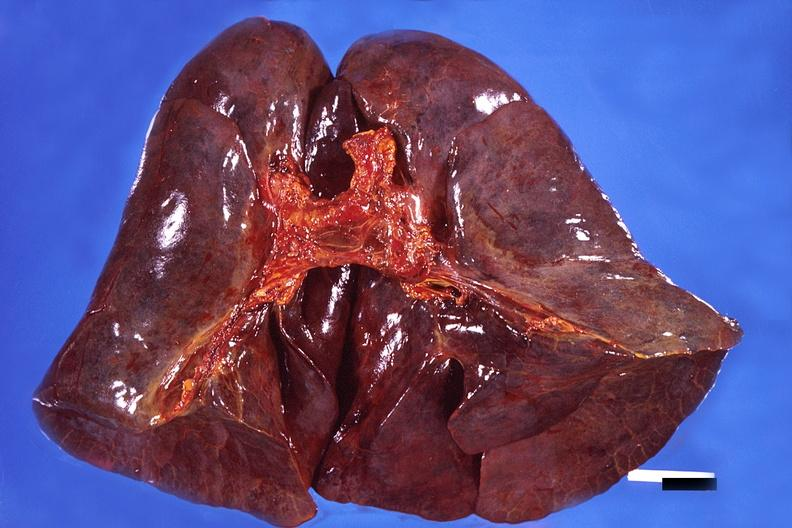where is this?
Answer the question using a single word or phrase. Lung 